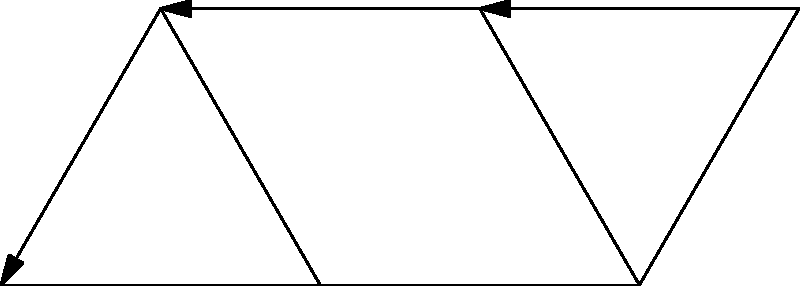In a money laundering investigation, you've identified a network of six key individuals (A, B, C, D, E, F) represented by the vertices in the graph. The directed edges represent known financial transactions. If we consider this network as a group with the operation of following transaction paths, and given that A and D are generators of this group, what is the minimum number of transactions needed to reach F from A? To solve this problem, we need to analyze the group structure and use the properties of group generators. Let's approach this step-by-step:

1) First, we need to understand what it means for A and D to be generators of the group. This implies that we can reach any vertex in the graph by combining paths starting from A and D.

2) Now, let's look at the paths from A:
   - A → B
   - A → B → C
   - A → B → D

3) And the paths from D:
   - D → E
   - D → F

4) Since A and D are generators, we need to find the shortest combination of these paths to reach F.

5) We can see that there's no direct path from A to F. However, we can reach D from A in two steps (A → B → D).

6) Once we're at D, we can reach F in one step (D → F).

7) Therefore, the minimum number of transactions needed is:
   2 (to get from A to D) + 1 (to get from D to F) = 3

This solution utilizes the group structure efficiently by using the generators to navigate the network.
Answer: 3 transactions 